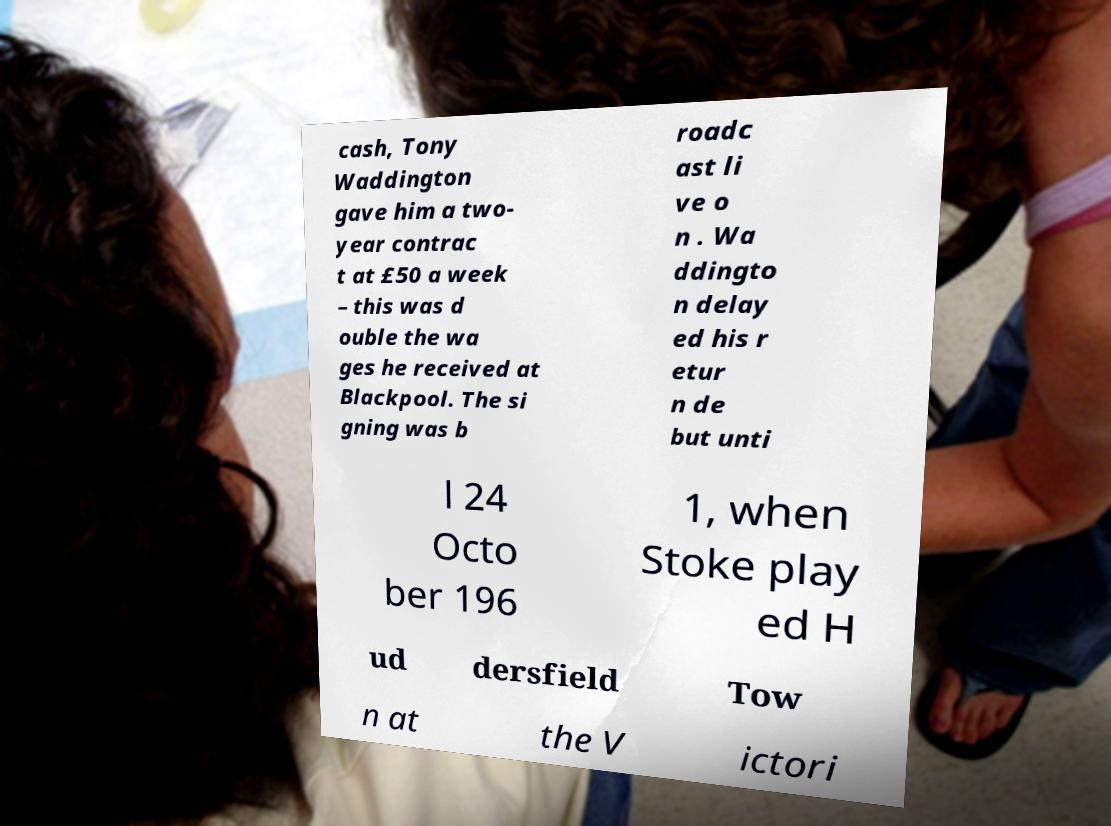What messages or text are displayed in this image? I need them in a readable, typed format. cash, Tony Waddington gave him a two- year contrac t at £50 a week – this was d ouble the wa ges he received at Blackpool. The si gning was b roadc ast li ve o n . Wa ddingto n delay ed his r etur n de but unti l 24 Octo ber 196 1, when Stoke play ed H ud dersfield Tow n at the V ictori 